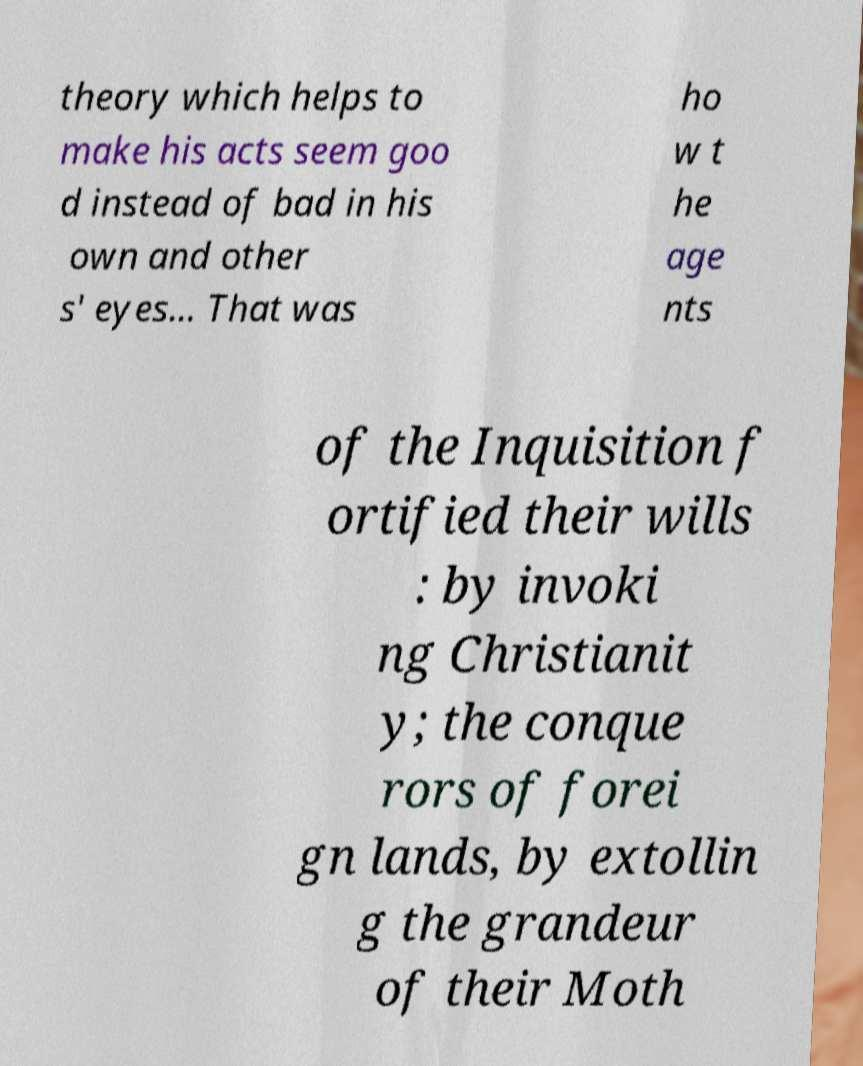For documentation purposes, I need the text within this image transcribed. Could you provide that? theory which helps to make his acts seem goo d instead of bad in his own and other s' eyes... That was ho w t he age nts of the Inquisition f ortified their wills : by invoki ng Christianit y; the conque rors of forei gn lands, by extollin g the grandeur of their Moth 